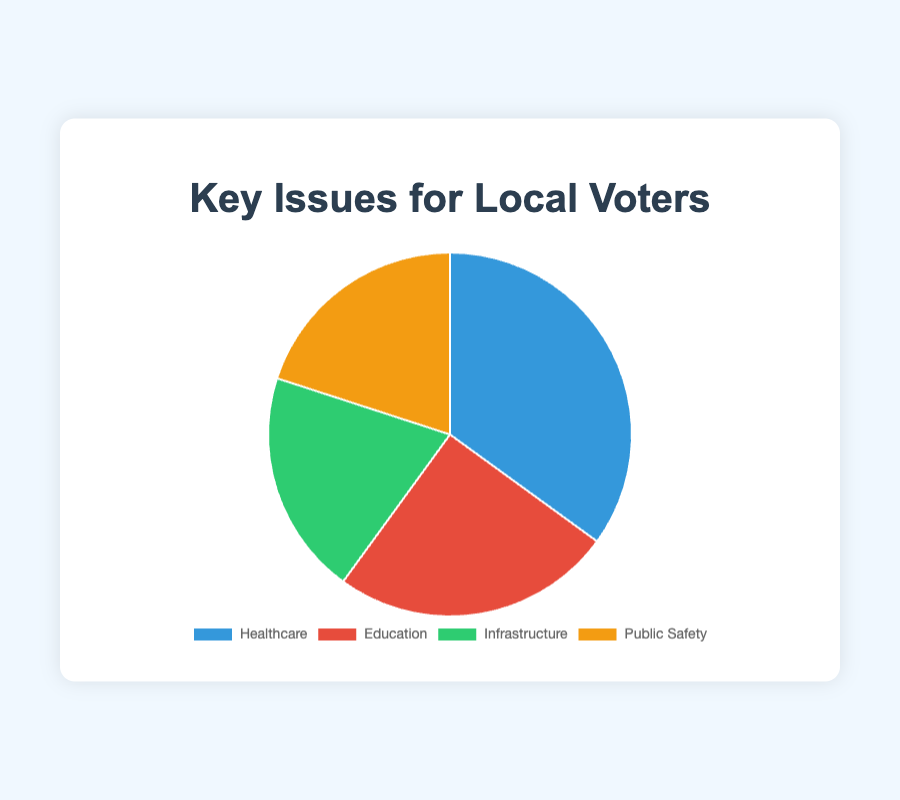What issue is the most important to local voters based on the survey? The issue with the highest percentage is the most important to voters. From the pie chart, Healthcare has the highest percentage at 35%.
Answer: Healthcare Which issues are equally important to local voters? By looking at the percentages on the pie chart, any issues with the same percentage value are equally important. Infrastructure and Public Safety both have 20%.
Answer: Infrastructure and Public Safety What is the total percentage of voters concerned with Education and Infrastructure combined? Add the percentages for Education and Infrastructure. Education is 25% and Infrastructure is 20%, so 25% + 20% = 45%.
Answer: 45% How much more important is Healthcare compared to Public Safety? Subtract the percentage of Public Safety from the percentage of Healthcare. Healthcare is 35%, and Public Safety is 20%, so 35% - 20% = 15%.
Answer: 15% What percentage of voters do not consider Healthcare the most important issue? Subtract the percentage of voters who consider Healthcare the most important from 100%. Healthcare is 35%, so 100% - 35% = 65%.
Answer: 65% Which color represents the Healthcare issue in the pie chart? The slice representing Healthcare is colored blue in the chart.
Answer: Blue If you were to combine the percentages of Infrastructure and Public Safety, would they exceed the percentage of Healthcare? Combine the percentages of Infrastructure and Public Safety and compare with Healthcare. Infrastructure is 20%, and Public Safety is 20%, so 20% + 20% = 40%. Healthcare is 35%, so 40% > 35%.
Answer: Yes What is the average percentage of the issues not related to Healthcare? Sum the percentages of Education, Infrastructure, and Public Safety, then divide by 3. Education 25%, Infrastructure 20%, Public Safety 20%; (25% + 20% + 20%) / 3 = 21.67%.
Answer: 21.67% 